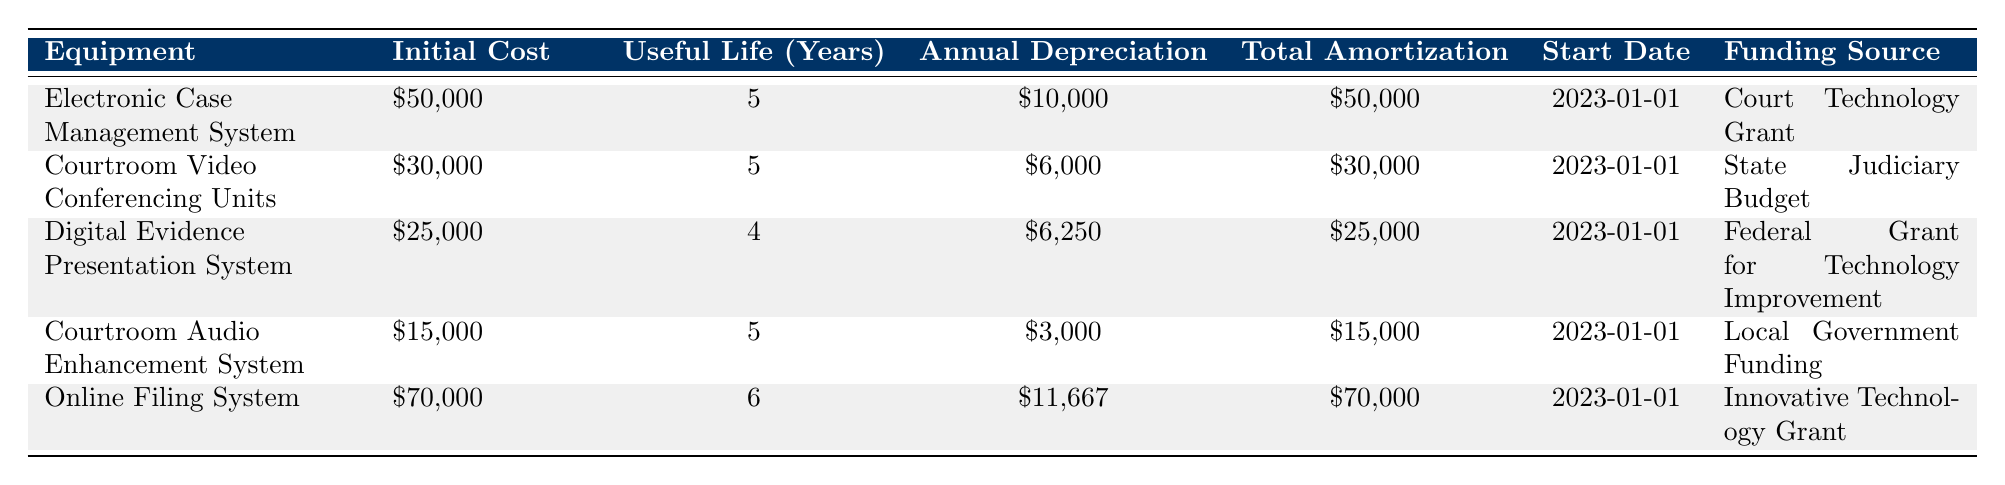What is the initial cost of the Courtroom Video Conferencing Units? The table lists the initial cost for each piece of equipment. For the Courtroom Video Conferencing Units, the initial cost is shown directly in the table as $30,000.
Answer: 30,000 How many pieces of equipment have a useful life of 5 years? By examining the "Useful Life (Years)" column, there are four pieces of equipment that have a useful life of 5 years: Electronic Case Management System, Courtroom Video Conferencing Units, Courtroom Audio Enhancement System, and Online Filing System.
Answer: 4 What is the total amortization for the Digital Evidence Presentation System? The total amortization for the Digital Evidence Presentation System is directly given in the table as $25,000.
Answer: 25,000 Which equipment has the highest annual depreciation? The table specifies annual depreciation for each piece of equipment. The Online Filing System has the highest annual depreciation at $11,667.
Answer: Online Filing System What is the average initial cost of the equipment listed in the table? To calculate the average initial cost, sum all the initial costs: 50,000 + 30,000 + 25,000 + 15,000 + 70,000 = 190,000. There are 5 pieces of equipment, so the average is 190,000 / 5 = 38,000.
Answer: 38,000 Is there any equipment funded by a State Judiciary Budget? By checking the "Funding Source" column, we find the Courtroom Video Conferencing Units is funded by the State Judiciary Budget.
Answer: Yes Which equipment has the longest useful life? The table shows the useful life for each piece of equipment. The Online Filing System has the longest useful life of 6 years.
Answer: Online Filing System What is the difference in total amortization between the equipment with the highest and lowest total amortization? The highest total amortization is for the Online Filing System at $70,000 and the lowest is for the Courtroom Audio Enhancement System at $15,000. The difference is 70,000 - 15,000 = 55,000.
Answer: 55,000 Are there any pieces of equipment with total amortization less than $30,000? Looking at the "Total Amortization" column, the Digital Evidence Presentation System and Courtroom Audio Enhancement System both have amortizations below $30,000, at $25,000 and $15,000 respectively.
Answer: Yes 